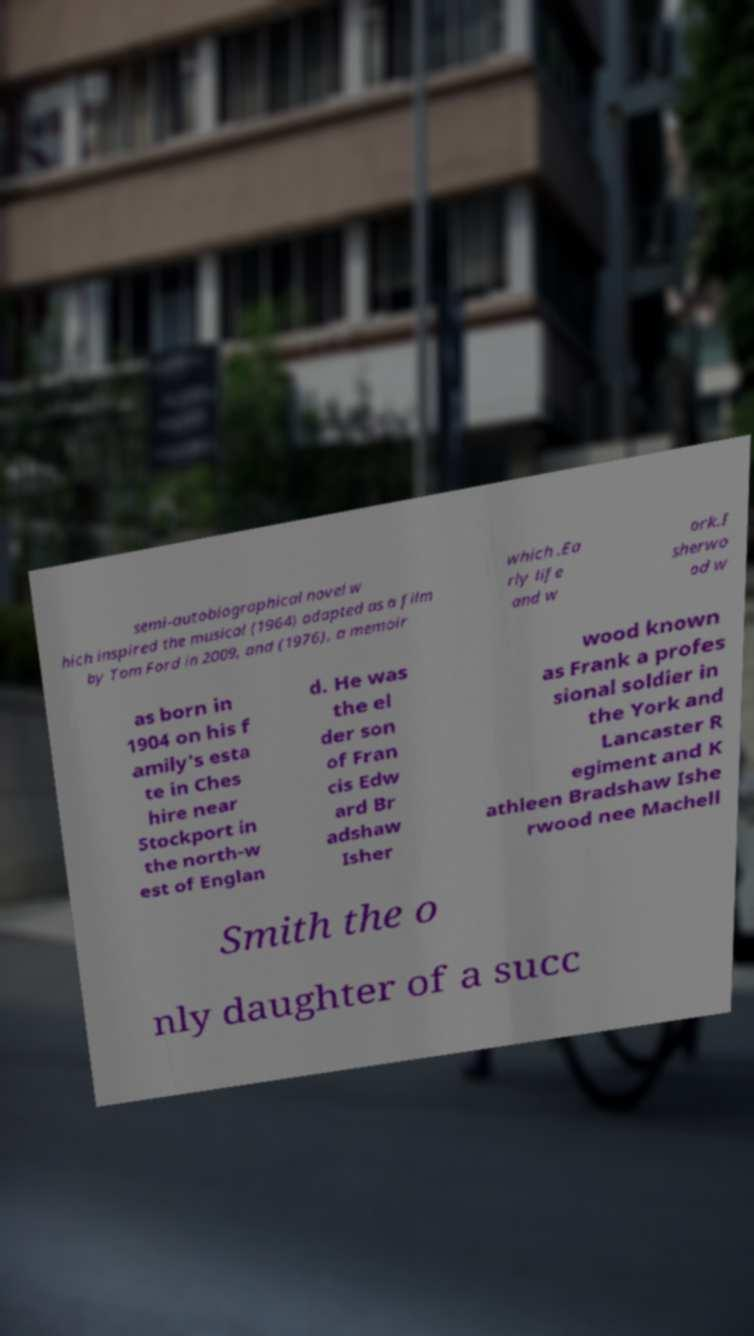For documentation purposes, I need the text within this image transcribed. Could you provide that? semi-autobiographical novel w hich inspired the musical (1964) adapted as a film by Tom Ford in 2009, and (1976), a memoir which .Ea rly life and w ork.I sherwo od w as born in 1904 on his f amily's esta te in Ches hire near Stockport in the north-w est of Englan d. He was the el der son of Fran cis Edw ard Br adshaw Isher wood known as Frank a profes sional soldier in the York and Lancaster R egiment and K athleen Bradshaw Ishe rwood nee Machell Smith the o nly daughter of a succ 